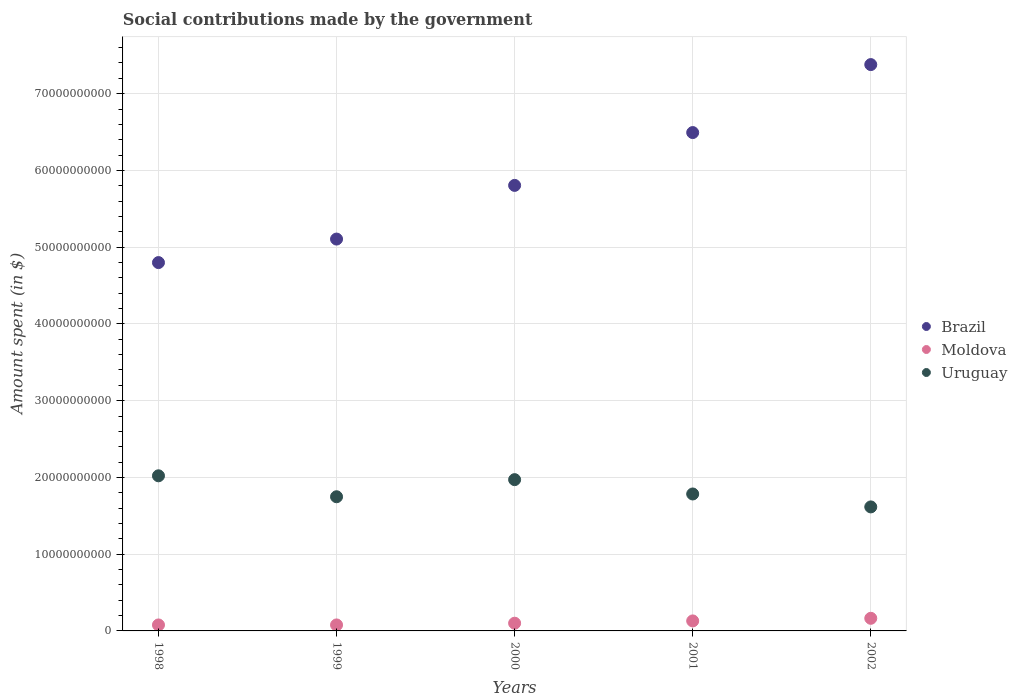What is the amount spent on social contributions in Moldova in 2001?
Provide a succinct answer. 1.30e+09. Across all years, what is the maximum amount spent on social contributions in Moldova?
Make the answer very short. 1.64e+09. Across all years, what is the minimum amount spent on social contributions in Moldova?
Keep it short and to the point. 7.80e+08. In which year was the amount spent on social contributions in Uruguay maximum?
Provide a short and direct response. 1998. What is the total amount spent on social contributions in Moldova in the graph?
Keep it short and to the point. 5.51e+09. What is the difference between the amount spent on social contributions in Uruguay in 2000 and that in 2002?
Offer a terse response. 3.55e+09. What is the difference between the amount spent on social contributions in Uruguay in 1998 and the amount spent on social contributions in Moldova in 2000?
Make the answer very short. 1.92e+1. What is the average amount spent on social contributions in Uruguay per year?
Ensure brevity in your answer.  1.83e+1. In the year 1999, what is the difference between the amount spent on social contributions in Moldova and amount spent on social contributions in Brazil?
Make the answer very short. -5.03e+1. What is the ratio of the amount spent on social contributions in Uruguay in 1999 to that in 2000?
Offer a terse response. 0.89. What is the difference between the highest and the second highest amount spent on social contributions in Brazil?
Give a very brief answer. 8.86e+09. What is the difference between the highest and the lowest amount spent on social contributions in Moldova?
Offer a terse response. 8.64e+08. In how many years, is the amount spent on social contributions in Uruguay greater than the average amount spent on social contributions in Uruguay taken over all years?
Ensure brevity in your answer.  2. Is the sum of the amount spent on social contributions in Uruguay in 1998 and 2002 greater than the maximum amount spent on social contributions in Moldova across all years?
Your answer should be very brief. Yes. Is it the case that in every year, the sum of the amount spent on social contributions in Moldova and amount spent on social contributions in Brazil  is greater than the amount spent on social contributions in Uruguay?
Your response must be concise. Yes. How many dotlines are there?
Offer a very short reply. 3. How many years are there in the graph?
Your answer should be compact. 5. What is the difference between two consecutive major ticks on the Y-axis?
Your answer should be compact. 1.00e+1. Are the values on the major ticks of Y-axis written in scientific E-notation?
Your response must be concise. No. How many legend labels are there?
Keep it short and to the point. 3. What is the title of the graph?
Make the answer very short. Social contributions made by the government. What is the label or title of the Y-axis?
Your answer should be compact. Amount spent (in $). What is the Amount spent (in $) in Brazil in 1998?
Your answer should be very brief. 4.80e+1. What is the Amount spent (in $) in Moldova in 1998?
Provide a succinct answer. 7.80e+08. What is the Amount spent (in $) in Uruguay in 1998?
Make the answer very short. 2.02e+1. What is the Amount spent (in $) in Brazil in 1999?
Your answer should be very brief. 5.11e+1. What is the Amount spent (in $) of Moldova in 1999?
Give a very brief answer. 7.81e+08. What is the Amount spent (in $) of Uruguay in 1999?
Your answer should be compact. 1.75e+1. What is the Amount spent (in $) in Brazil in 2000?
Give a very brief answer. 5.81e+1. What is the Amount spent (in $) of Moldova in 2000?
Provide a succinct answer. 1.00e+09. What is the Amount spent (in $) in Uruguay in 2000?
Give a very brief answer. 1.97e+1. What is the Amount spent (in $) of Brazil in 2001?
Make the answer very short. 6.49e+1. What is the Amount spent (in $) in Moldova in 2001?
Your response must be concise. 1.30e+09. What is the Amount spent (in $) of Uruguay in 2001?
Ensure brevity in your answer.  1.78e+1. What is the Amount spent (in $) in Brazil in 2002?
Offer a very short reply. 7.38e+1. What is the Amount spent (in $) of Moldova in 2002?
Make the answer very short. 1.64e+09. What is the Amount spent (in $) in Uruguay in 2002?
Ensure brevity in your answer.  1.62e+1. Across all years, what is the maximum Amount spent (in $) of Brazil?
Your answer should be compact. 7.38e+1. Across all years, what is the maximum Amount spent (in $) of Moldova?
Keep it short and to the point. 1.64e+09. Across all years, what is the maximum Amount spent (in $) of Uruguay?
Your answer should be compact. 2.02e+1. Across all years, what is the minimum Amount spent (in $) in Brazil?
Your response must be concise. 4.80e+1. Across all years, what is the minimum Amount spent (in $) in Moldova?
Your answer should be compact. 7.80e+08. Across all years, what is the minimum Amount spent (in $) of Uruguay?
Ensure brevity in your answer.  1.62e+1. What is the total Amount spent (in $) of Brazil in the graph?
Your answer should be very brief. 2.96e+11. What is the total Amount spent (in $) in Moldova in the graph?
Your response must be concise. 5.51e+09. What is the total Amount spent (in $) of Uruguay in the graph?
Keep it short and to the point. 9.14e+1. What is the difference between the Amount spent (in $) of Brazil in 1998 and that in 1999?
Make the answer very short. -3.06e+09. What is the difference between the Amount spent (in $) of Moldova in 1998 and that in 1999?
Ensure brevity in your answer.  -1.70e+06. What is the difference between the Amount spent (in $) of Uruguay in 1998 and that in 1999?
Your answer should be very brief. 2.73e+09. What is the difference between the Amount spent (in $) of Brazil in 1998 and that in 2000?
Offer a terse response. -1.01e+1. What is the difference between the Amount spent (in $) of Moldova in 1998 and that in 2000?
Give a very brief answer. -2.26e+08. What is the difference between the Amount spent (in $) in Uruguay in 1998 and that in 2000?
Your answer should be compact. 5.01e+08. What is the difference between the Amount spent (in $) in Brazil in 1998 and that in 2001?
Your answer should be very brief. -1.69e+1. What is the difference between the Amount spent (in $) in Moldova in 1998 and that in 2001?
Your response must be concise. -5.24e+08. What is the difference between the Amount spent (in $) of Uruguay in 1998 and that in 2001?
Your response must be concise. 2.37e+09. What is the difference between the Amount spent (in $) in Brazil in 1998 and that in 2002?
Provide a short and direct response. -2.58e+1. What is the difference between the Amount spent (in $) in Moldova in 1998 and that in 2002?
Ensure brevity in your answer.  -8.64e+08. What is the difference between the Amount spent (in $) of Uruguay in 1998 and that in 2002?
Your response must be concise. 4.05e+09. What is the difference between the Amount spent (in $) in Brazil in 1999 and that in 2000?
Your answer should be compact. -6.99e+09. What is the difference between the Amount spent (in $) of Moldova in 1999 and that in 2000?
Give a very brief answer. -2.24e+08. What is the difference between the Amount spent (in $) in Uruguay in 1999 and that in 2000?
Make the answer very short. -2.23e+09. What is the difference between the Amount spent (in $) in Brazil in 1999 and that in 2001?
Your answer should be very brief. -1.39e+1. What is the difference between the Amount spent (in $) in Moldova in 1999 and that in 2001?
Provide a succinct answer. -5.22e+08. What is the difference between the Amount spent (in $) of Uruguay in 1999 and that in 2001?
Provide a short and direct response. -3.61e+08. What is the difference between the Amount spent (in $) of Brazil in 1999 and that in 2002?
Your answer should be very brief. -2.27e+1. What is the difference between the Amount spent (in $) of Moldova in 1999 and that in 2002?
Your answer should be very brief. -8.63e+08. What is the difference between the Amount spent (in $) of Uruguay in 1999 and that in 2002?
Provide a succinct answer. 1.32e+09. What is the difference between the Amount spent (in $) in Brazil in 2000 and that in 2001?
Offer a very short reply. -6.88e+09. What is the difference between the Amount spent (in $) in Moldova in 2000 and that in 2001?
Make the answer very short. -2.99e+08. What is the difference between the Amount spent (in $) in Uruguay in 2000 and that in 2001?
Keep it short and to the point. 1.87e+09. What is the difference between the Amount spent (in $) in Brazil in 2000 and that in 2002?
Give a very brief answer. -1.57e+1. What is the difference between the Amount spent (in $) of Moldova in 2000 and that in 2002?
Your response must be concise. -6.39e+08. What is the difference between the Amount spent (in $) in Uruguay in 2000 and that in 2002?
Your response must be concise. 3.55e+09. What is the difference between the Amount spent (in $) in Brazil in 2001 and that in 2002?
Offer a very short reply. -8.86e+09. What is the difference between the Amount spent (in $) in Moldova in 2001 and that in 2002?
Provide a short and direct response. -3.40e+08. What is the difference between the Amount spent (in $) in Uruguay in 2001 and that in 2002?
Provide a succinct answer. 1.68e+09. What is the difference between the Amount spent (in $) of Brazil in 1998 and the Amount spent (in $) of Moldova in 1999?
Provide a succinct answer. 4.72e+1. What is the difference between the Amount spent (in $) of Brazil in 1998 and the Amount spent (in $) of Uruguay in 1999?
Your response must be concise. 3.05e+1. What is the difference between the Amount spent (in $) of Moldova in 1998 and the Amount spent (in $) of Uruguay in 1999?
Offer a very short reply. -1.67e+1. What is the difference between the Amount spent (in $) in Brazil in 1998 and the Amount spent (in $) in Moldova in 2000?
Your answer should be compact. 4.70e+1. What is the difference between the Amount spent (in $) in Brazil in 1998 and the Amount spent (in $) in Uruguay in 2000?
Provide a succinct answer. 2.83e+1. What is the difference between the Amount spent (in $) in Moldova in 1998 and the Amount spent (in $) in Uruguay in 2000?
Keep it short and to the point. -1.89e+1. What is the difference between the Amount spent (in $) of Brazil in 1998 and the Amount spent (in $) of Moldova in 2001?
Your answer should be compact. 4.67e+1. What is the difference between the Amount spent (in $) of Brazil in 1998 and the Amount spent (in $) of Uruguay in 2001?
Offer a terse response. 3.02e+1. What is the difference between the Amount spent (in $) of Moldova in 1998 and the Amount spent (in $) of Uruguay in 2001?
Your answer should be compact. -1.71e+1. What is the difference between the Amount spent (in $) in Brazil in 1998 and the Amount spent (in $) in Moldova in 2002?
Your answer should be compact. 4.63e+1. What is the difference between the Amount spent (in $) of Brazil in 1998 and the Amount spent (in $) of Uruguay in 2002?
Provide a succinct answer. 3.18e+1. What is the difference between the Amount spent (in $) of Moldova in 1998 and the Amount spent (in $) of Uruguay in 2002?
Make the answer very short. -1.54e+1. What is the difference between the Amount spent (in $) of Brazil in 1999 and the Amount spent (in $) of Moldova in 2000?
Your response must be concise. 5.01e+1. What is the difference between the Amount spent (in $) of Brazil in 1999 and the Amount spent (in $) of Uruguay in 2000?
Make the answer very short. 3.13e+1. What is the difference between the Amount spent (in $) in Moldova in 1999 and the Amount spent (in $) in Uruguay in 2000?
Your response must be concise. -1.89e+1. What is the difference between the Amount spent (in $) of Brazil in 1999 and the Amount spent (in $) of Moldova in 2001?
Your answer should be very brief. 4.98e+1. What is the difference between the Amount spent (in $) in Brazil in 1999 and the Amount spent (in $) in Uruguay in 2001?
Provide a succinct answer. 3.32e+1. What is the difference between the Amount spent (in $) in Moldova in 1999 and the Amount spent (in $) in Uruguay in 2001?
Ensure brevity in your answer.  -1.71e+1. What is the difference between the Amount spent (in $) in Brazil in 1999 and the Amount spent (in $) in Moldova in 2002?
Offer a very short reply. 4.94e+1. What is the difference between the Amount spent (in $) in Brazil in 1999 and the Amount spent (in $) in Uruguay in 2002?
Make the answer very short. 3.49e+1. What is the difference between the Amount spent (in $) in Moldova in 1999 and the Amount spent (in $) in Uruguay in 2002?
Provide a short and direct response. -1.54e+1. What is the difference between the Amount spent (in $) in Brazil in 2000 and the Amount spent (in $) in Moldova in 2001?
Offer a terse response. 5.67e+1. What is the difference between the Amount spent (in $) of Brazil in 2000 and the Amount spent (in $) of Uruguay in 2001?
Keep it short and to the point. 4.02e+1. What is the difference between the Amount spent (in $) of Moldova in 2000 and the Amount spent (in $) of Uruguay in 2001?
Your response must be concise. -1.68e+1. What is the difference between the Amount spent (in $) of Brazil in 2000 and the Amount spent (in $) of Moldova in 2002?
Offer a very short reply. 5.64e+1. What is the difference between the Amount spent (in $) of Brazil in 2000 and the Amount spent (in $) of Uruguay in 2002?
Provide a succinct answer. 4.19e+1. What is the difference between the Amount spent (in $) in Moldova in 2000 and the Amount spent (in $) in Uruguay in 2002?
Your answer should be very brief. -1.52e+1. What is the difference between the Amount spent (in $) of Brazil in 2001 and the Amount spent (in $) of Moldova in 2002?
Provide a short and direct response. 6.33e+1. What is the difference between the Amount spent (in $) of Brazil in 2001 and the Amount spent (in $) of Uruguay in 2002?
Provide a short and direct response. 4.88e+1. What is the difference between the Amount spent (in $) in Moldova in 2001 and the Amount spent (in $) in Uruguay in 2002?
Your answer should be compact. -1.49e+1. What is the average Amount spent (in $) in Brazil per year?
Provide a short and direct response. 5.92e+1. What is the average Amount spent (in $) of Moldova per year?
Provide a succinct answer. 1.10e+09. What is the average Amount spent (in $) in Uruguay per year?
Give a very brief answer. 1.83e+1. In the year 1998, what is the difference between the Amount spent (in $) in Brazil and Amount spent (in $) in Moldova?
Keep it short and to the point. 4.72e+1. In the year 1998, what is the difference between the Amount spent (in $) of Brazil and Amount spent (in $) of Uruguay?
Your response must be concise. 2.78e+1. In the year 1998, what is the difference between the Amount spent (in $) in Moldova and Amount spent (in $) in Uruguay?
Make the answer very short. -1.94e+1. In the year 1999, what is the difference between the Amount spent (in $) of Brazil and Amount spent (in $) of Moldova?
Make the answer very short. 5.03e+1. In the year 1999, what is the difference between the Amount spent (in $) in Brazil and Amount spent (in $) in Uruguay?
Your answer should be very brief. 3.36e+1. In the year 1999, what is the difference between the Amount spent (in $) of Moldova and Amount spent (in $) of Uruguay?
Offer a terse response. -1.67e+1. In the year 2000, what is the difference between the Amount spent (in $) in Brazil and Amount spent (in $) in Moldova?
Offer a terse response. 5.70e+1. In the year 2000, what is the difference between the Amount spent (in $) in Brazil and Amount spent (in $) in Uruguay?
Keep it short and to the point. 3.83e+1. In the year 2000, what is the difference between the Amount spent (in $) of Moldova and Amount spent (in $) of Uruguay?
Keep it short and to the point. -1.87e+1. In the year 2001, what is the difference between the Amount spent (in $) of Brazil and Amount spent (in $) of Moldova?
Your response must be concise. 6.36e+1. In the year 2001, what is the difference between the Amount spent (in $) in Brazil and Amount spent (in $) in Uruguay?
Ensure brevity in your answer.  4.71e+1. In the year 2001, what is the difference between the Amount spent (in $) of Moldova and Amount spent (in $) of Uruguay?
Ensure brevity in your answer.  -1.65e+1. In the year 2002, what is the difference between the Amount spent (in $) in Brazil and Amount spent (in $) in Moldova?
Your answer should be compact. 7.21e+1. In the year 2002, what is the difference between the Amount spent (in $) of Brazil and Amount spent (in $) of Uruguay?
Keep it short and to the point. 5.76e+1. In the year 2002, what is the difference between the Amount spent (in $) in Moldova and Amount spent (in $) in Uruguay?
Your answer should be compact. -1.45e+1. What is the ratio of the Amount spent (in $) in Moldova in 1998 to that in 1999?
Your answer should be very brief. 1. What is the ratio of the Amount spent (in $) of Uruguay in 1998 to that in 1999?
Keep it short and to the point. 1.16. What is the ratio of the Amount spent (in $) of Brazil in 1998 to that in 2000?
Make the answer very short. 0.83. What is the ratio of the Amount spent (in $) in Moldova in 1998 to that in 2000?
Ensure brevity in your answer.  0.78. What is the ratio of the Amount spent (in $) in Uruguay in 1998 to that in 2000?
Ensure brevity in your answer.  1.03. What is the ratio of the Amount spent (in $) of Brazil in 1998 to that in 2001?
Offer a very short reply. 0.74. What is the ratio of the Amount spent (in $) of Moldova in 1998 to that in 2001?
Offer a terse response. 0.6. What is the ratio of the Amount spent (in $) of Uruguay in 1998 to that in 2001?
Offer a very short reply. 1.13. What is the ratio of the Amount spent (in $) in Brazil in 1998 to that in 2002?
Your answer should be very brief. 0.65. What is the ratio of the Amount spent (in $) in Moldova in 1998 to that in 2002?
Provide a succinct answer. 0.47. What is the ratio of the Amount spent (in $) of Uruguay in 1998 to that in 2002?
Offer a very short reply. 1.25. What is the ratio of the Amount spent (in $) in Brazil in 1999 to that in 2000?
Your answer should be compact. 0.88. What is the ratio of the Amount spent (in $) of Moldova in 1999 to that in 2000?
Keep it short and to the point. 0.78. What is the ratio of the Amount spent (in $) of Uruguay in 1999 to that in 2000?
Keep it short and to the point. 0.89. What is the ratio of the Amount spent (in $) in Brazil in 1999 to that in 2001?
Your answer should be very brief. 0.79. What is the ratio of the Amount spent (in $) of Moldova in 1999 to that in 2001?
Your answer should be very brief. 0.6. What is the ratio of the Amount spent (in $) of Uruguay in 1999 to that in 2001?
Ensure brevity in your answer.  0.98. What is the ratio of the Amount spent (in $) in Brazil in 1999 to that in 2002?
Your answer should be compact. 0.69. What is the ratio of the Amount spent (in $) in Moldova in 1999 to that in 2002?
Your answer should be compact. 0.48. What is the ratio of the Amount spent (in $) of Uruguay in 1999 to that in 2002?
Offer a very short reply. 1.08. What is the ratio of the Amount spent (in $) of Brazil in 2000 to that in 2001?
Provide a short and direct response. 0.89. What is the ratio of the Amount spent (in $) of Moldova in 2000 to that in 2001?
Your answer should be compact. 0.77. What is the ratio of the Amount spent (in $) of Uruguay in 2000 to that in 2001?
Provide a short and direct response. 1.1. What is the ratio of the Amount spent (in $) in Brazil in 2000 to that in 2002?
Your answer should be compact. 0.79. What is the ratio of the Amount spent (in $) in Moldova in 2000 to that in 2002?
Keep it short and to the point. 0.61. What is the ratio of the Amount spent (in $) of Uruguay in 2000 to that in 2002?
Make the answer very short. 1.22. What is the ratio of the Amount spent (in $) in Moldova in 2001 to that in 2002?
Make the answer very short. 0.79. What is the ratio of the Amount spent (in $) in Uruguay in 2001 to that in 2002?
Offer a terse response. 1.1. What is the difference between the highest and the second highest Amount spent (in $) in Brazil?
Give a very brief answer. 8.86e+09. What is the difference between the highest and the second highest Amount spent (in $) of Moldova?
Make the answer very short. 3.40e+08. What is the difference between the highest and the second highest Amount spent (in $) in Uruguay?
Offer a very short reply. 5.01e+08. What is the difference between the highest and the lowest Amount spent (in $) of Brazil?
Provide a succinct answer. 2.58e+1. What is the difference between the highest and the lowest Amount spent (in $) in Moldova?
Your answer should be very brief. 8.64e+08. What is the difference between the highest and the lowest Amount spent (in $) in Uruguay?
Ensure brevity in your answer.  4.05e+09. 